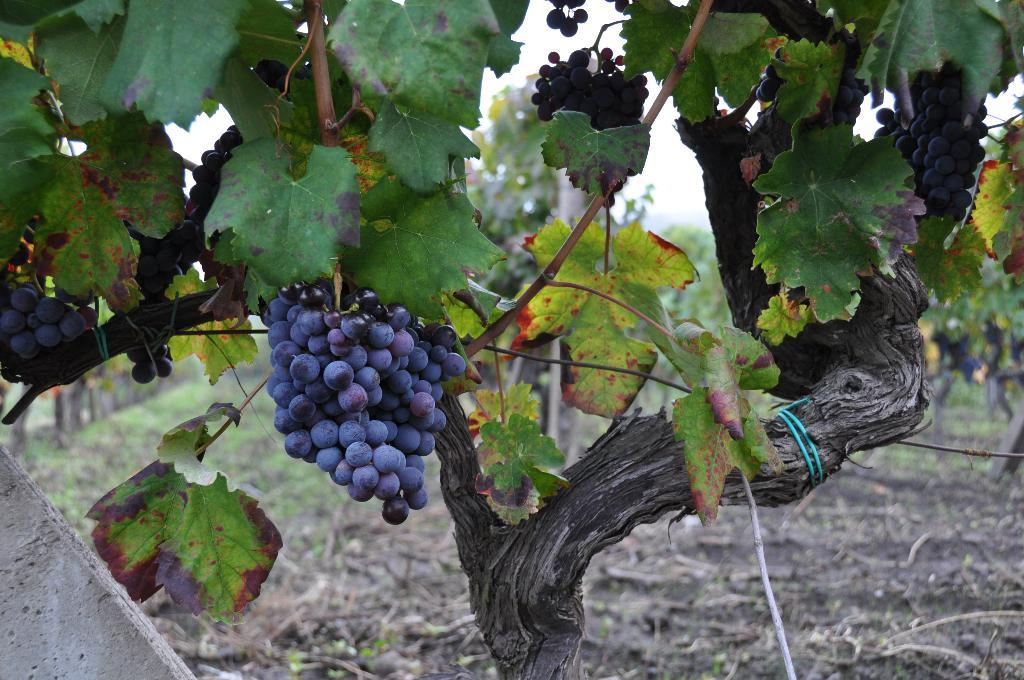What is the main subject of the image? The main subject of the image is a tree with fruits. Can you describe the background of the image? There are trees in the background of the image, and the sky is also visible. What type of celery can be seen growing on the tree in the image? There is no celery present in the image; the tree has fruits, not celery. 